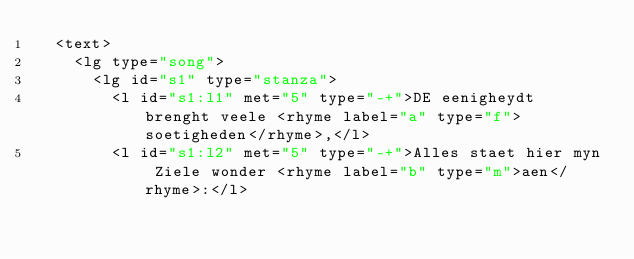<code> <loc_0><loc_0><loc_500><loc_500><_XML_>  <text>
    <lg type="song">
      <lg id="s1" type="stanza">
        <l id="s1:l1" met="5" type="-+">DE eenigheydt brenght veele <rhyme label="a" type="f">soetigheden</rhyme>,</l>
        <l id="s1:l2" met="5" type="-+">Alles staet hier myn Ziele wonder <rhyme label="b" type="m">aen</rhyme>:</l></code> 